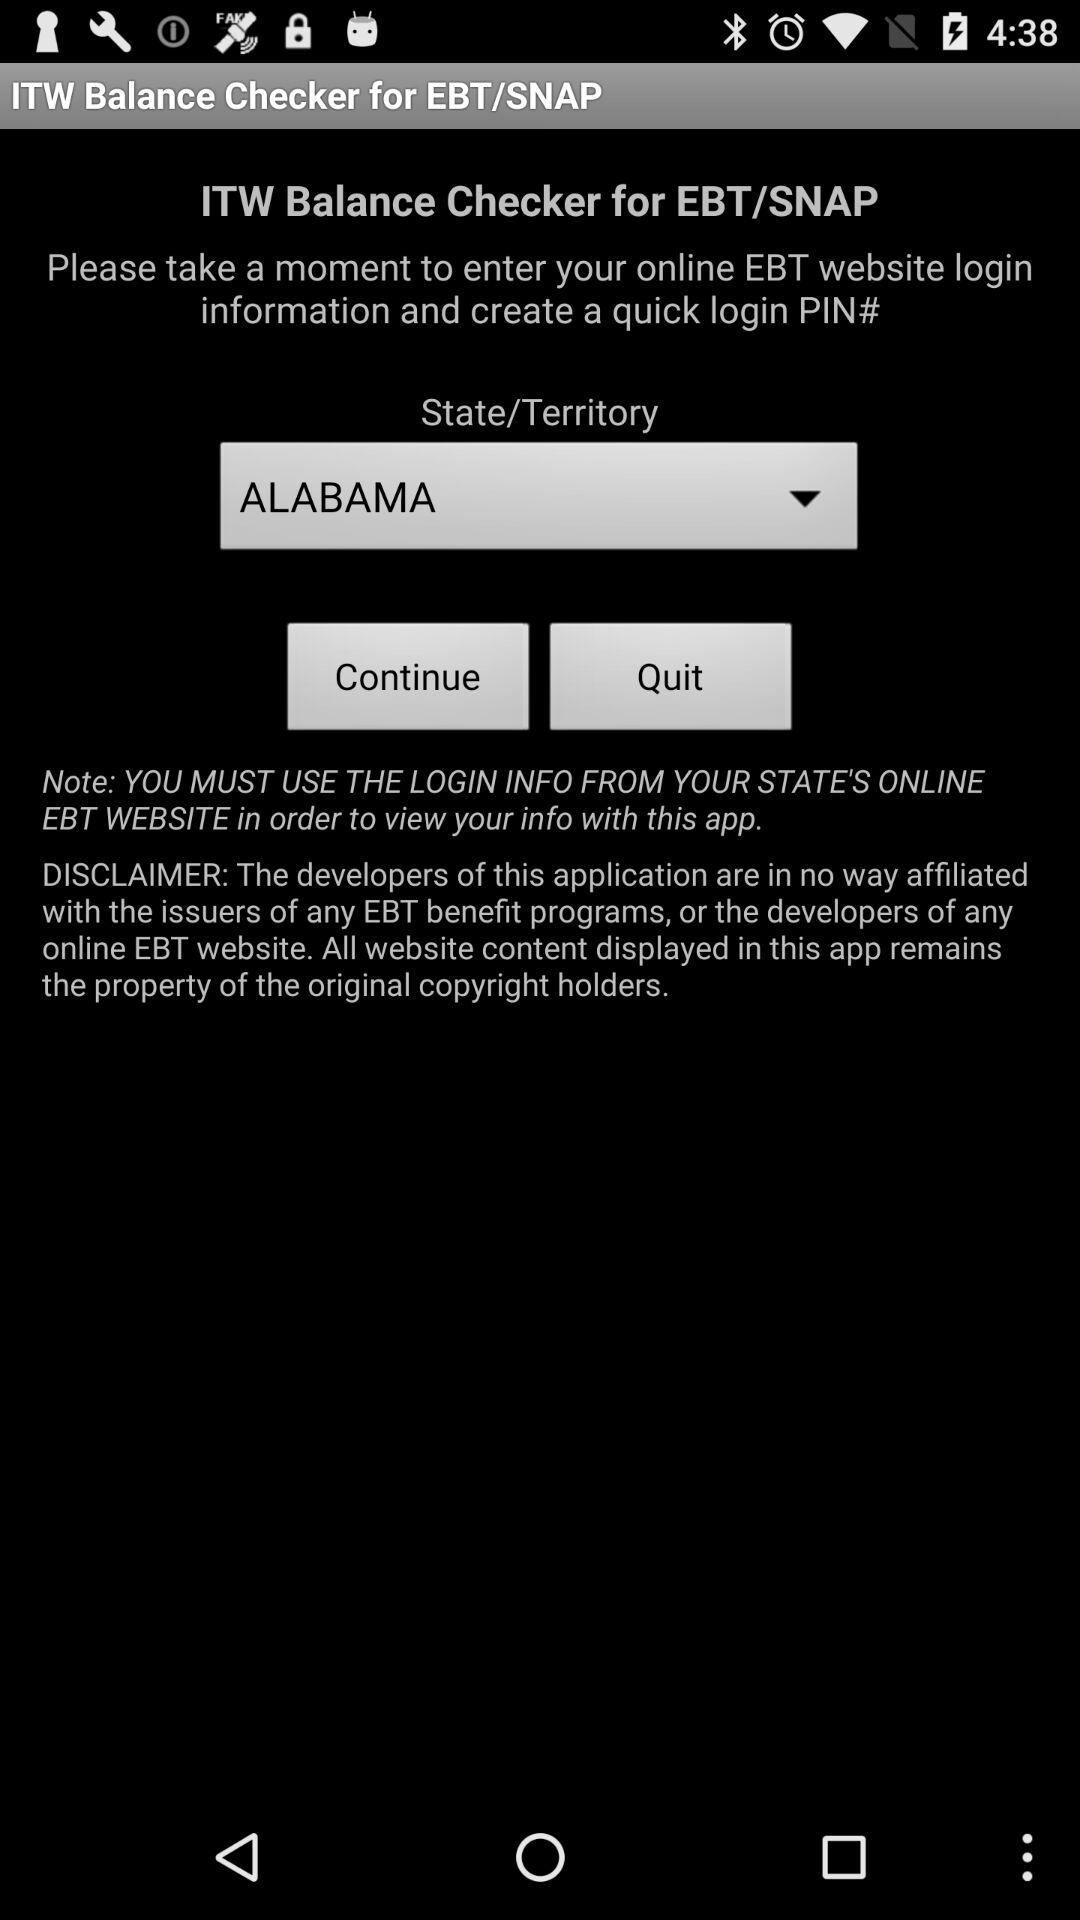Which state has been selected? The selected state is Alabama. 